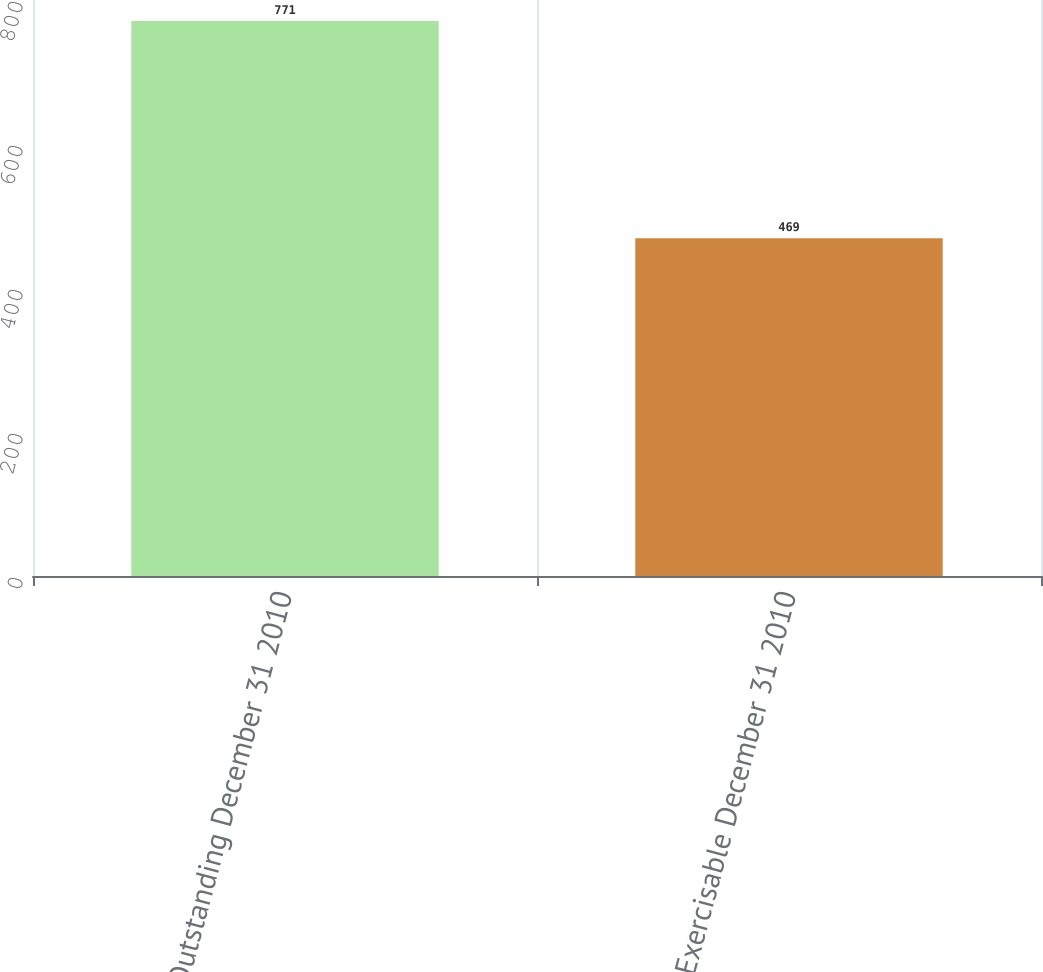Convert chart. <chart><loc_0><loc_0><loc_500><loc_500><bar_chart><fcel>Outstanding December 31 2010<fcel>Exercisable December 31 2010<nl><fcel>771<fcel>469<nl></chart> 